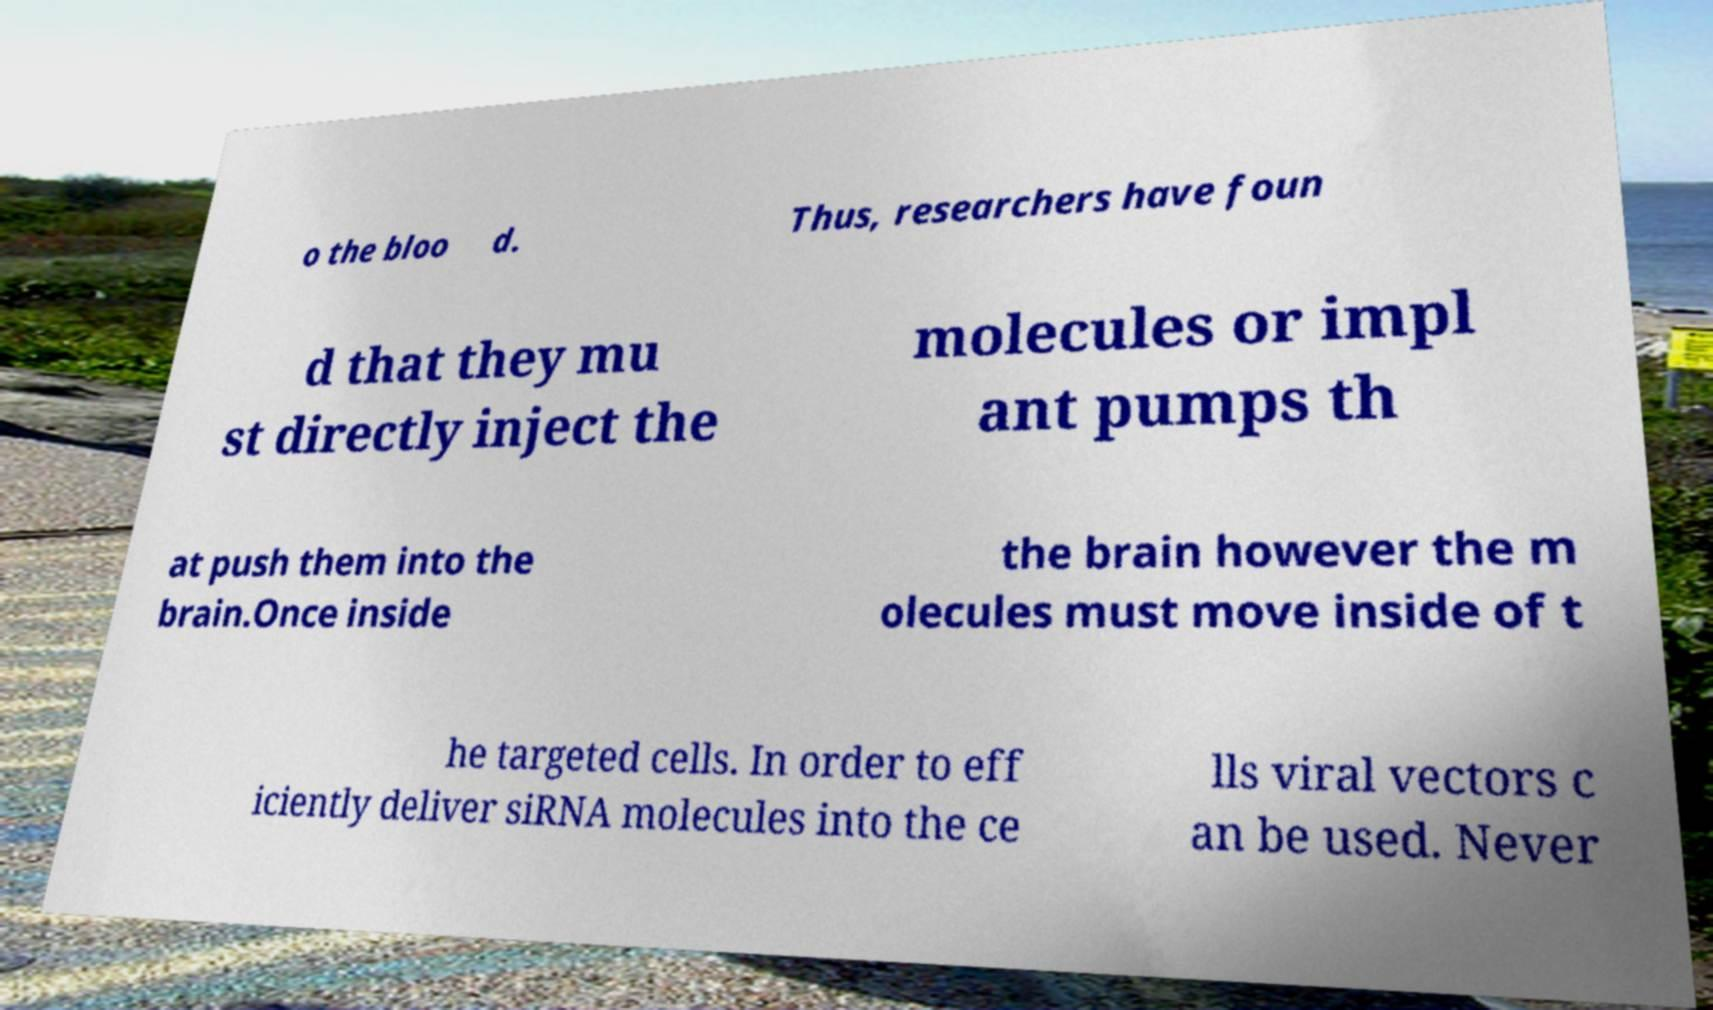Can you read and provide the text displayed in the image?This photo seems to have some interesting text. Can you extract and type it out for me? o the bloo d. Thus, researchers have foun d that they mu st directly inject the molecules or impl ant pumps th at push them into the brain.Once inside the brain however the m olecules must move inside of t he targeted cells. In order to eff iciently deliver siRNA molecules into the ce lls viral vectors c an be used. Never 